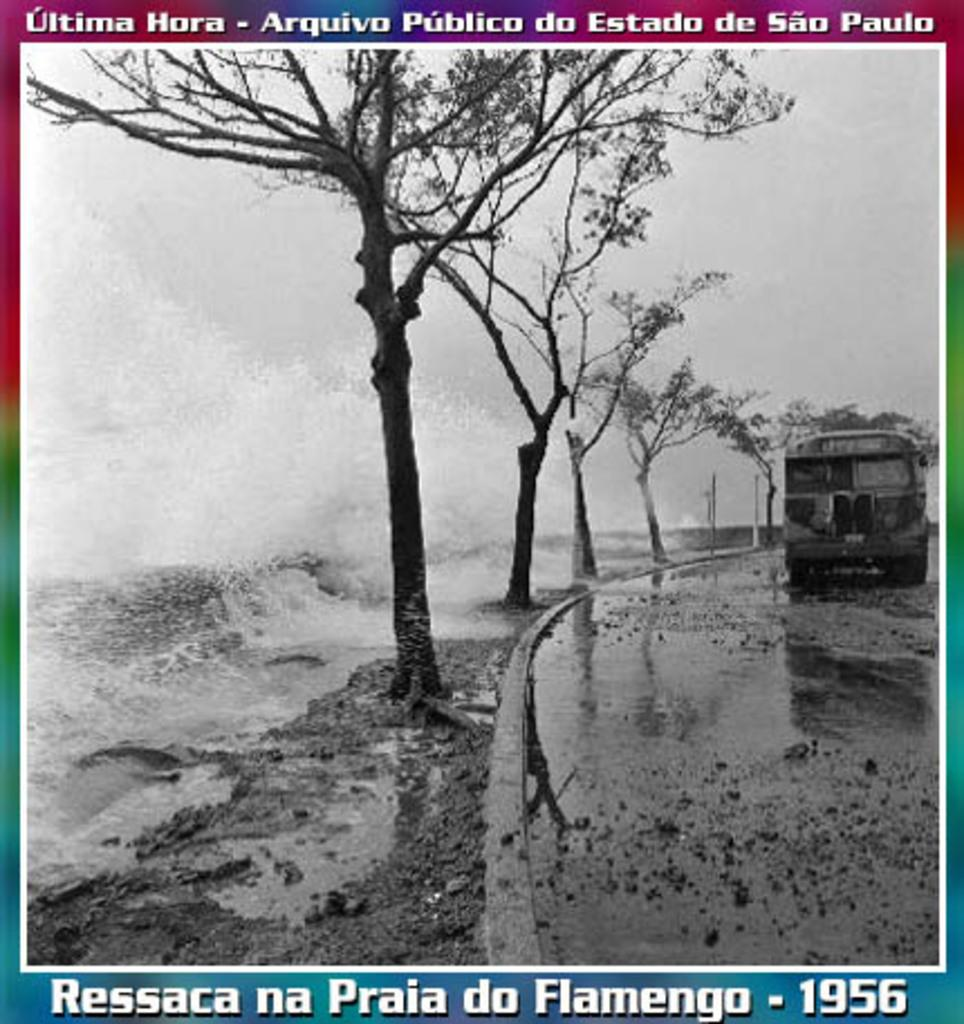<image>
Describe the image concisely. A picture of trees says "Ressaca na Praia do Flamengo - 1956" on the bottom. 